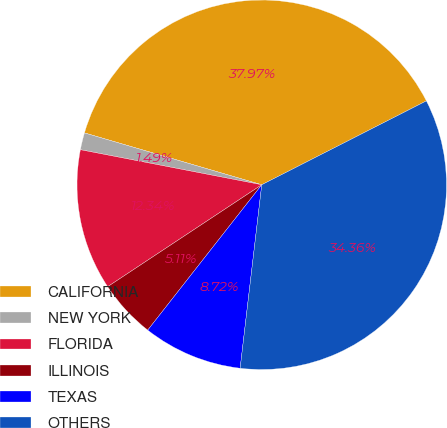Convert chart. <chart><loc_0><loc_0><loc_500><loc_500><pie_chart><fcel>CALIFORNIA<fcel>NEW YORK<fcel>FLORIDA<fcel>ILLINOIS<fcel>TEXAS<fcel>OTHERS<nl><fcel>37.97%<fcel>1.49%<fcel>12.34%<fcel>5.11%<fcel>8.72%<fcel>34.36%<nl></chart> 